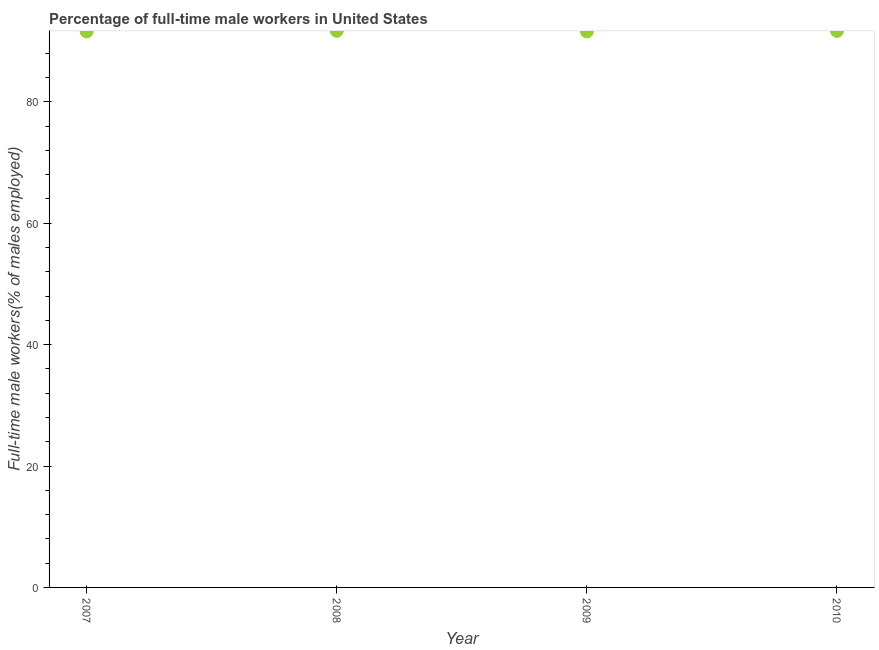What is the percentage of full-time male workers in 2007?
Your response must be concise. 91.6. Across all years, what is the maximum percentage of full-time male workers?
Make the answer very short. 91.7. Across all years, what is the minimum percentage of full-time male workers?
Your answer should be very brief. 91.6. What is the sum of the percentage of full-time male workers?
Your answer should be very brief. 366.6. What is the difference between the percentage of full-time male workers in 2009 and 2010?
Keep it short and to the point. -0.1. What is the average percentage of full-time male workers per year?
Offer a very short reply. 91.65. What is the median percentage of full-time male workers?
Your response must be concise. 91.65. What is the ratio of the percentage of full-time male workers in 2007 to that in 2010?
Your answer should be very brief. 1. Is the percentage of full-time male workers in 2008 less than that in 2009?
Make the answer very short. No. What is the difference between the highest and the second highest percentage of full-time male workers?
Give a very brief answer. 0. What is the difference between the highest and the lowest percentage of full-time male workers?
Provide a succinct answer. 0.1. How many dotlines are there?
Your response must be concise. 1. Does the graph contain grids?
Provide a succinct answer. No. What is the title of the graph?
Ensure brevity in your answer.  Percentage of full-time male workers in United States. What is the label or title of the X-axis?
Keep it short and to the point. Year. What is the label or title of the Y-axis?
Provide a short and direct response. Full-time male workers(% of males employed). What is the Full-time male workers(% of males employed) in 2007?
Offer a very short reply. 91.6. What is the Full-time male workers(% of males employed) in 2008?
Your answer should be very brief. 91.7. What is the Full-time male workers(% of males employed) in 2009?
Your answer should be very brief. 91.6. What is the Full-time male workers(% of males employed) in 2010?
Ensure brevity in your answer.  91.7. What is the difference between the Full-time male workers(% of males employed) in 2007 and 2010?
Give a very brief answer. -0.1. What is the difference between the Full-time male workers(% of males employed) in 2008 and 2009?
Make the answer very short. 0.1. What is the difference between the Full-time male workers(% of males employed) in 2008 and 2010?
Provide a short and direct response. 0. What is the ratio of the Full-time male workers(% of males employed) in 2007 to that in 2008?
Offer a very short reply. 1. What is the ratio of the Full-time male workers(% of males employed) in 2007 to that in 2009?
Keep it short and to the point. 1. What is the ratio of the Full-time male workers(% of males employed) in 2008 to that in 2009?
Ensure brevity in your answer.  1. What is the ratio of the Full-time male workers(% of males employed) in 2008 to that in 2010?
Offer a terse response. 1. 